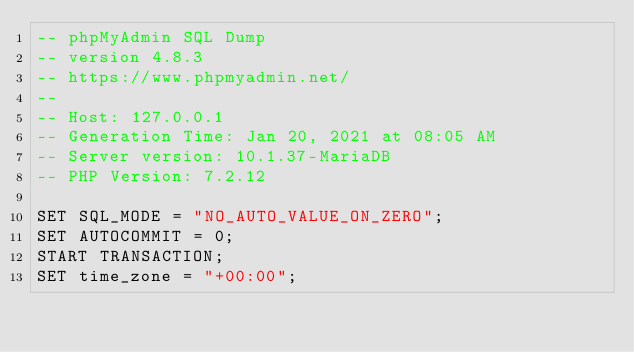Convert code to text. <code><loc_0><loc_0><loc_500><loc_500><_SQL_>-- phpMyAdmin SQL Dump
-- version 4.8.3
-- https://www.phpmyadmin.net/
--
-- Host: 127.0.0.1
-- Generation Time: Jan 20, 2021 at 08:05 AM
-- Server version: 10.1.37-MariaDB
-- PHP Version: 7.2.12

SET SQL_MODE = "NO_AUTO_VALUE_ON_ZERO";
SET AUTOCOMMIT = 0;
START TRANSACTION;
SET time_zone = "+00:00";

</code> 